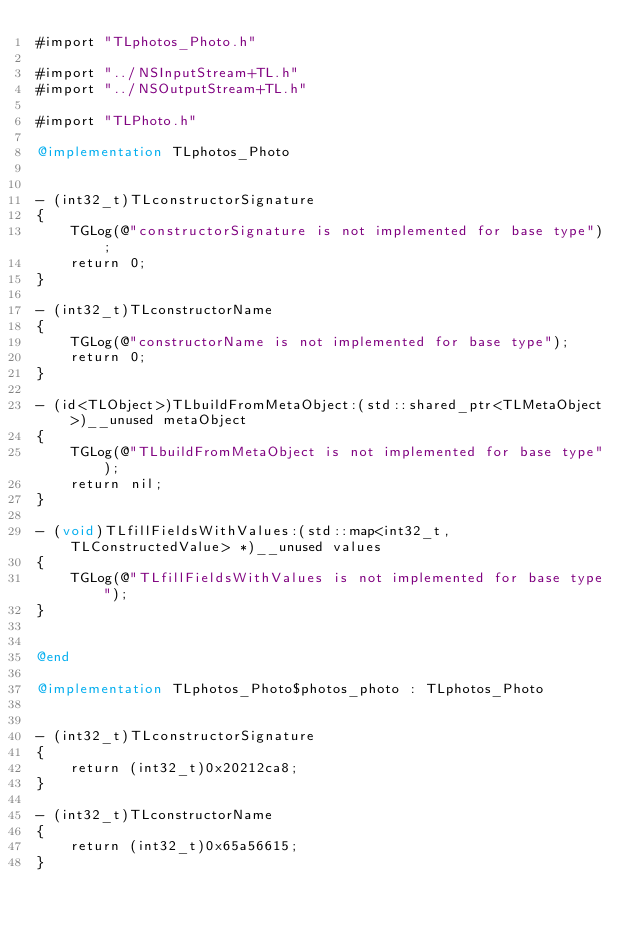Convert code to text. <code><loc_0><loc_0><loc_500><loc_500><_ObjectiveC_>#import "TLphotos_Photo.h"

#import "../NSInputStream+TL.h"
#import "../NSOutputStream+TL.h"

#import "TLPhoto.h"

@implementation TLphotos_Photo


- (int32_t)TLconstructorSignature
{
    TGLog(@"constructorSignature is not implemented for base type");
    return 0;
}

- (int32_t)TLconstructorName
{
    TGLog(@"constructorName is not implemented for base type");
    return 0;
}

- (id<TLObject>)TLbuildFromMetaObject:(std::shared_ptr<TLMetaObject>)__unused metaObject
{
    TGLog(@"TLbuildFromMetaObject is not implemented for base type");
    return nil;
}

- (void)TLfillFieldsWithValues:(std::map<int32_t, TLConstructedValue> *)__unused values
{
    TGLog(@"TLfillFieldsWithValues is not implemented for base type");
}


@end

@implementation TLphotos_Photo$photos_photo : TLphotos_Photo


- (int32_t)TLconstructorSignature
{
    return (int32_t)0x20212ca8;
}

- (int32_t)TLconstructorName
{
    return (int32_t)0x65a56615;
}
</code> 